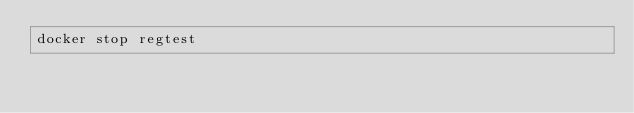Convert code to text. <code><loc_0><loc_0><loc_500><loc_500><_Bash_>docker stop regtest</code> 